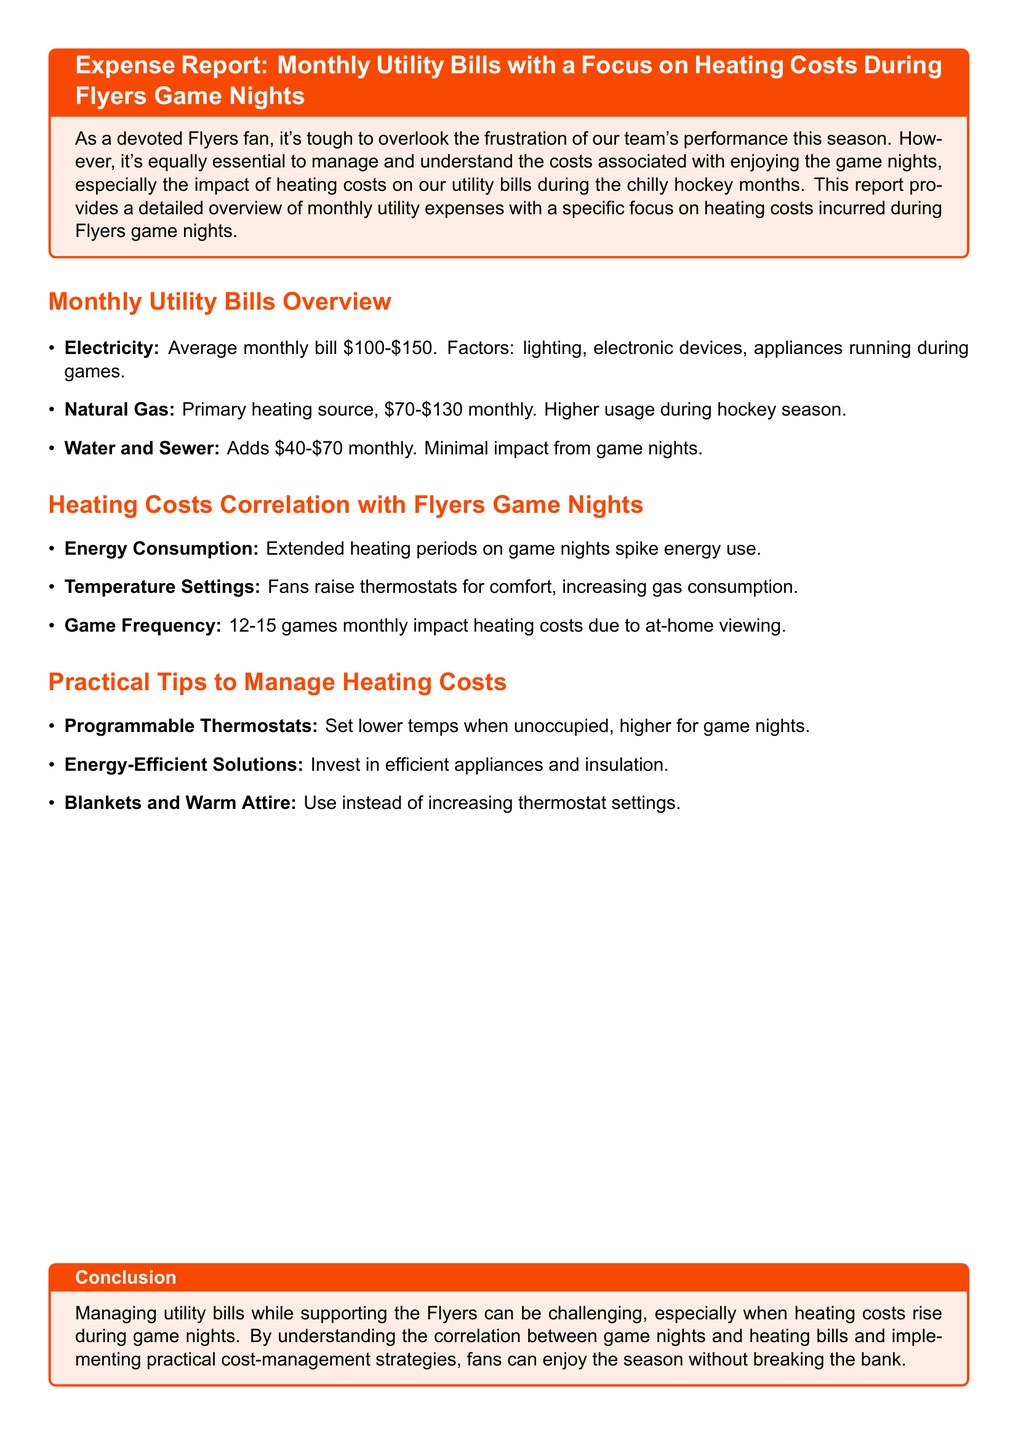what is the average monthly electricity bill? The document states that the average monthly electricity bill is between $100 and $150.
Answer: $100-$150 what is the primary heating source mentioned in the report? The report identifies natural gas as the primary heating source.
Answer: natural gas how much higher is the natural gas usage during the hockey season? The report mentions that natural gas usage is higher during the hockey season but does not specify an amount.
Answer: Higher usage how many games does the report indicate are played at home monthly? The document states that there are 12-15 games played at home monthly.
Answer: 12-15 games what is one practical tip to manage heating costs? The report suggests using programmable thermostats as a practical tip to manage heating costs.
Answer: Programmable Thermostats what color is the box highlighting the expense report title? The color of the box highlighting the expense report title is described as flyers orange.
Answer: flyers orange how much does water and sewer add to the monthly expenses? According to the document, water and sewer add between $40 and $70 to the monthly expenses.
Answer: $40-$70 what is one alternative to increasing thermostat settings mentioned in the report? The report suggests using blankets and warm attire instead of increasing thermostat settings.
Answer: Blankets and Warm Attire what is the correlation discussed between heating costs and game nights? The document discusses that extended heating periods and raised thermostat settings on game nights contribute to increased heating costs.
Answer: Increased heating costs 